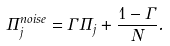<formula> <loc_0><loc_0><loc_500><loc_500>\Pi _ { j } ^ { n o i s e } = \Gamma \Pi _ { j } + \frac { 1 - \Gamma } { N } .</formula> 